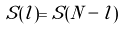<formula> <loc_0><loc_0><loc_500><loc_500>S ( l ) = S ( N - l )</formula> 